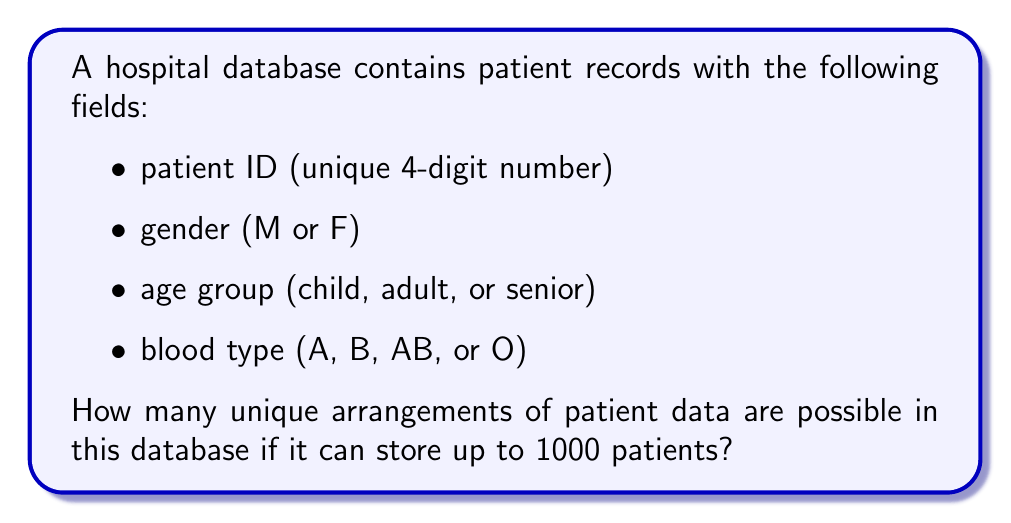Can you answer this question? Let's break this down step-by-step:

1) Patient ID: There are 9000 possible 4-digit numbers (1000 to 9999), but we only need 1000 of them.
   $${1000 \choose 1000} = 1$$ way to choose these IDs.

2) Gender: For each patient, there are 2 possibilities (M or F).

3) Age group: For each patient, there are 3 possibilities (child, adult, senior).

4) Blood type: For each patient, there are 4 possibilities (A, B, AB, O).

5) For each patient, we have:
   $$2 \times 3 \times 4 = 24$$ possible combinations of gender, age group, and blood type.

6) Using the multiplication principle, for 1000 patients, we have:
   $$24^{1000}$$ possible arrangements of gender, age group, and blood type.

7) Combining this with the patient ID selection:
   $$1 \times 24^{1000}$$ total unique arrangements.

This represents the total number of ways to arrange the data for 1000 patients in the database.
Answer: $$24^{1000}$$ 